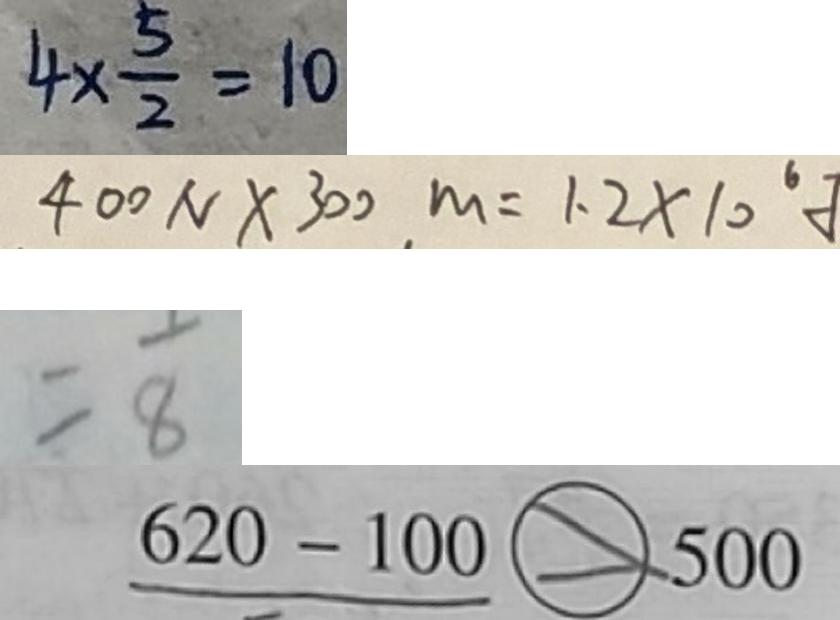<formula> <loc_0><loc_0><loc_500><loc_500>4 \times \frac { 5 } { 2 } = 1 0 
 4 0 0 N \times 3 0 0 m = 1 . 2 \times 1 0 ^ { 6 } 
 = \frac { 1 } { 8 } 
 6 2 0 - 1 0 0 > 5 0 0</formula> 